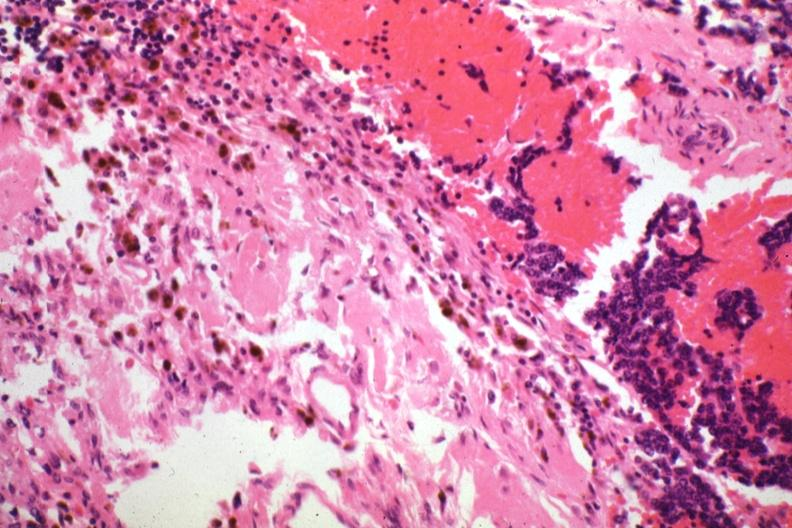s endocrine present?
Answer the question using a single word or phrase. Yes 